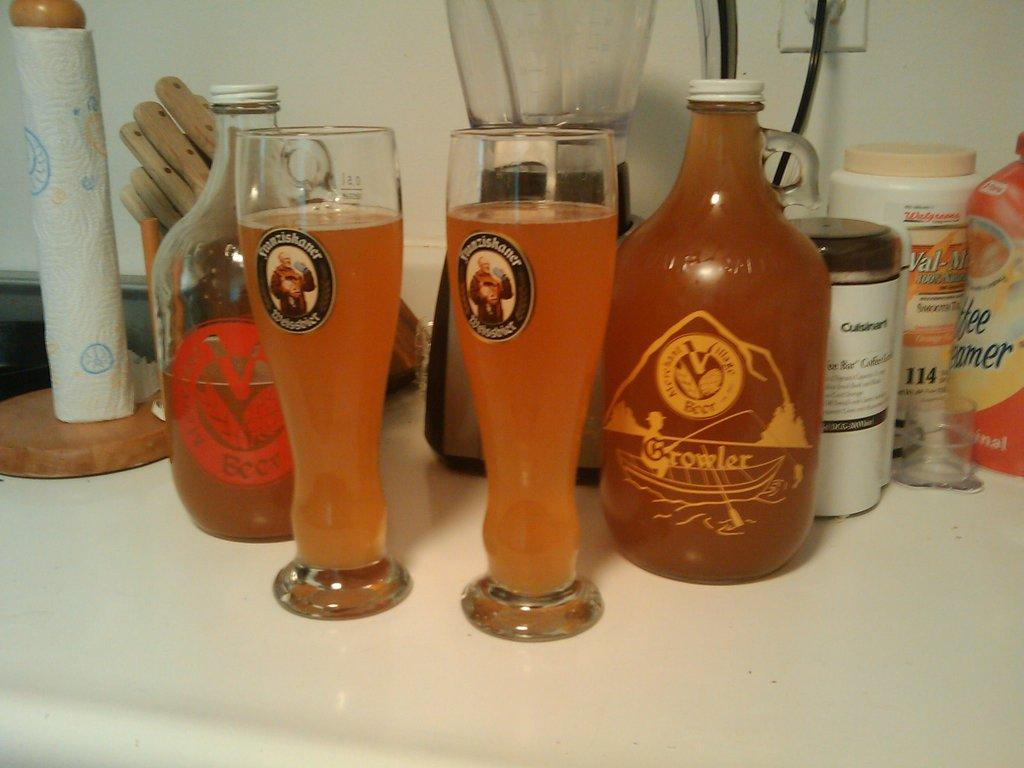<image>
Summarize the visual content of the image. Two glasses and jug of Growler beer on a counter. 